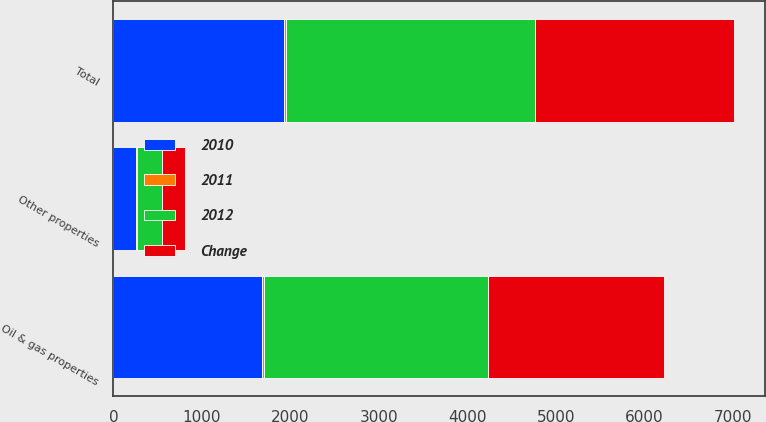Convert chart to OTSL. <chart><loc_0><loc_0><loc_500><loc_500><stacked_bar_chart><ecel><fcel>Oil & gas properties<fcel>Other properties<fcel>Total<nl><fcel>2012<fcel>2526<fcel>285<fcel>2811<nl><fcel>2011<fcel>27<fcel>9<fcel>25<nl><fcel>Change<fcel>1987<fcel>261<fcel>2248<nl><fcel>2010<fcel>1675<fcel>255<fcel>1930<nl></chart> 